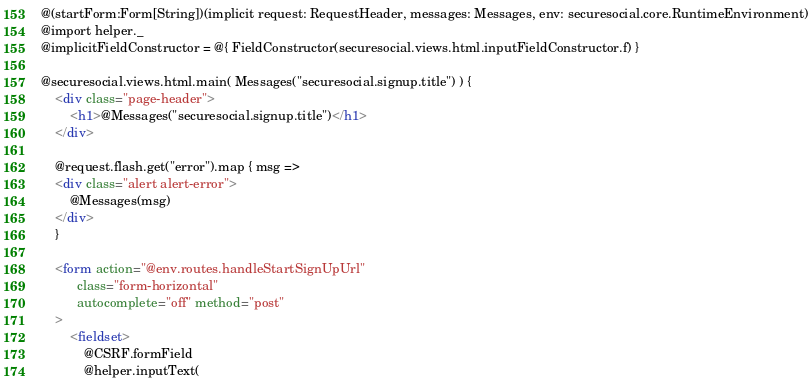<code> <loc_0><loc_0><loc_500><loc_500><_HTML_>@(startForm:Form[String])(implicit request: RequestHeader, messages: Messages, env: securesocial.core.RuntimeEnvironment)
@import helper._
@implicitFieldConstructor = @{ FieldConstructor(securesocial.views.html.inputFieldConstructor.f) }

@securesocial.views.html.main( Messages("securesocial.signup.title") ) {
    <div class="page-header">
        <h1>@Messages("securesocial.signup.title")</h1>
    </div>

    @request.flash.get("error").map { msg =>
    <div class="alert alert-error">
        @Messages(msg)
    </div>
    }

    <form action="@env.routes.handleStartSignUpUrl"
          class="form-horizontal"
          autocomplete="off" method="post"
    >
        <fieldset>
            @CSRF.formField
            @helper.inputText(</code> 